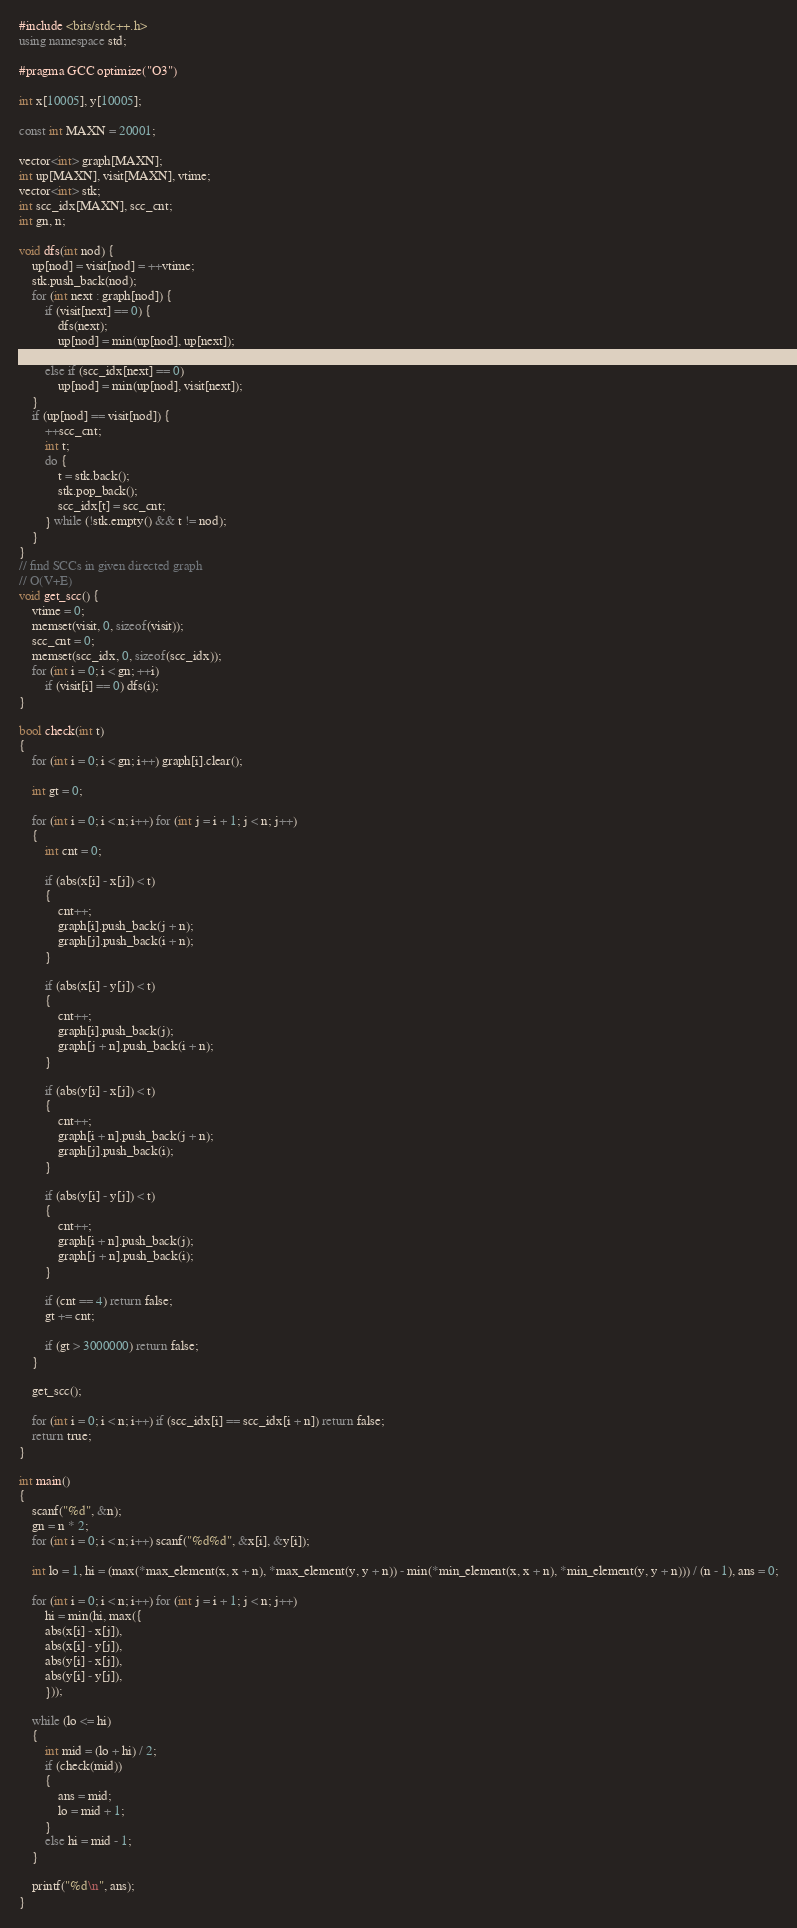Convert code to text. <code><loc_0><loc_0><loc_500><loc_500><_C++_>#include <bits/stdc++.h>
using namespace std;

#pragma GCC optimize("O3")

int x[10005], y[10005];

const int MAXN = 20001;

vector<int> graph[MAXN];
int up[MAXN], visit[MAXN], vtime;
vector<int> stk;
int scc_idx[MAXN], scc_cnt;
int gn, n;

void dfs(int nod) {
	up[nod] = visit[nod] = ++vtime;
	stk.push_back(nod);
	for (int next : graph[nod]) {
		if (visit[next] == 0) {
			dfs(next);
			up[nod] = min(up[nod], up[next]);
		}
		else if (scc_idx[next] == 0)
			up[nod] = min(up[nod], visit[next]);
	}
	if (up[nod] == visit[nod]) {
		++scc_cnt;
		int t;
		do {
			t = stk.back();
			stk.pop_back();
			scc_idx[t] = scc_cnt;
		} while (!stk.empty() && t != nod);
	}
}
// find SCCs in given directed graph
// O(V+E)
void get_scc() {
	vtime = 0;
	memset(visit, 0, sizeof(visit));
	scc_cnt = 0;
	memset(scc_idx, 0, sizeof(scc_idx));
	for (int i = 0; i < gn; ++i)
		if (visit[i] == 0) dfs(i);
}

bool check(int t)
{
	for (int i = 0; i < gn; i++) graph[i].clear();

	int gt = 0;

	for (int i = 0; i < n; i++) for (int j = i + 1; j < n; j++)
	{
		int cnt = 0;

		if (abs(x[i] - x[j]) < t)
		{
			cnt++;
			graph[i].push_back(j + n);
			graph[j].push_back(i + n);
		}

		if (abs(x[i] - y[j]) < t)
		{
			cnt++;
			graph[i].push_back(j);
			graph[j + n].push_back(i + n);
		}

		if (abs(y[i] - x[j]) < t)
		{
			cnt++;
			graph[i + n].push_back(j + n);
			graph[j].push_back(i);
		}

		if (abs(y[i] - y[j]) < t)
		{
			cnt++;
			graph[i + n].push_back(j);
			graph[j + n].push_back(i);
		}

		if (cnt == 4) return false;
		gt += cnt;

		if (gt > 3000000) return false;
	}

	get_scc();

	for (int i = 0; i < n; i++) if (scc_idx[i] == scc_idx[i + n]) return false;
	return true;
}

int main()
{
	scanf("%d", &n);
	gn = n * 2;
	for (int i = 0; i < n; i++) scanf("%d%d", &x[i], &y[i]);

	int lo = 1, hi = (max(*max_element(x, x + n), *max_element(y, y + n)) - min(*min_element(x, x + n), *min_element(y, y + n))) / (n - 1), ans = 0;

	for (int i = 0; i < n; i++) for (int j = i + 1; j < n; j++)
		hi = min(hi, max({
		abs(x[i] - x[j]),
		abs(x[i] - y[j]),
		abs(y[i] - x[j]),
		abs(y[i] - y[j]),
		}));

	while (lo <= hi)
	{
		int mid = (lo + hi) / 2;
		if (check(mid))
		{
			ans = mid;
			lo = mid + 1;
		}
		else hi = mid - 1;
	}

	printf("%d\n", ans);
}</code> 